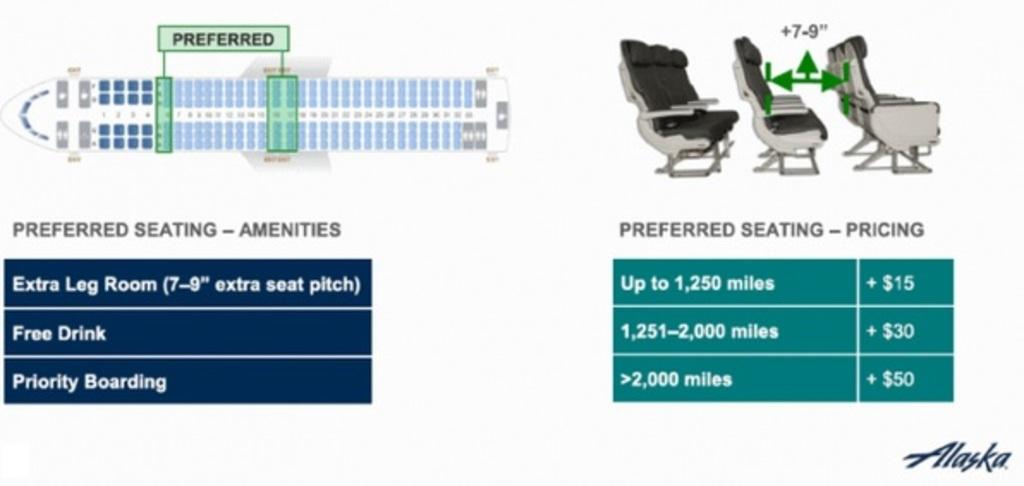What can be seen in the image related to seating? There is a seating arrangement and a seat diagram in the image. What type of information is visible on the sheet in the image? There is a sheet of the flight with some information in the image. Reasoning: Let'g: Let's think step by step in order to produce the conversation. We start by identifying the main subjects in the image, which are related to seating arrangements and flight information. We then formulate questions that focus on the specific details of these subjects, ensuring that each question can be answered definitively with the information given. We avoid yes/no questions and ensure that the language is simple and clear. Absurd Question/Answer: Can you see any snails crawling on the seating arrangement in the image? There are no snails present in the image; it features a seating arrangement and flight information. How many letters are visible on the sheet in the image? The question cannot be answered definitively as the number of letters is not mentioned in the provided facts. Can you see any snails crawling on the seating arrangement in the image? There are no snails present in the image; it features a seating arrangement and flight information. How many letters are visible on the sheet in the image? The question cannot be answered definitively as the number of letters is not mentioned in the provided facts. 